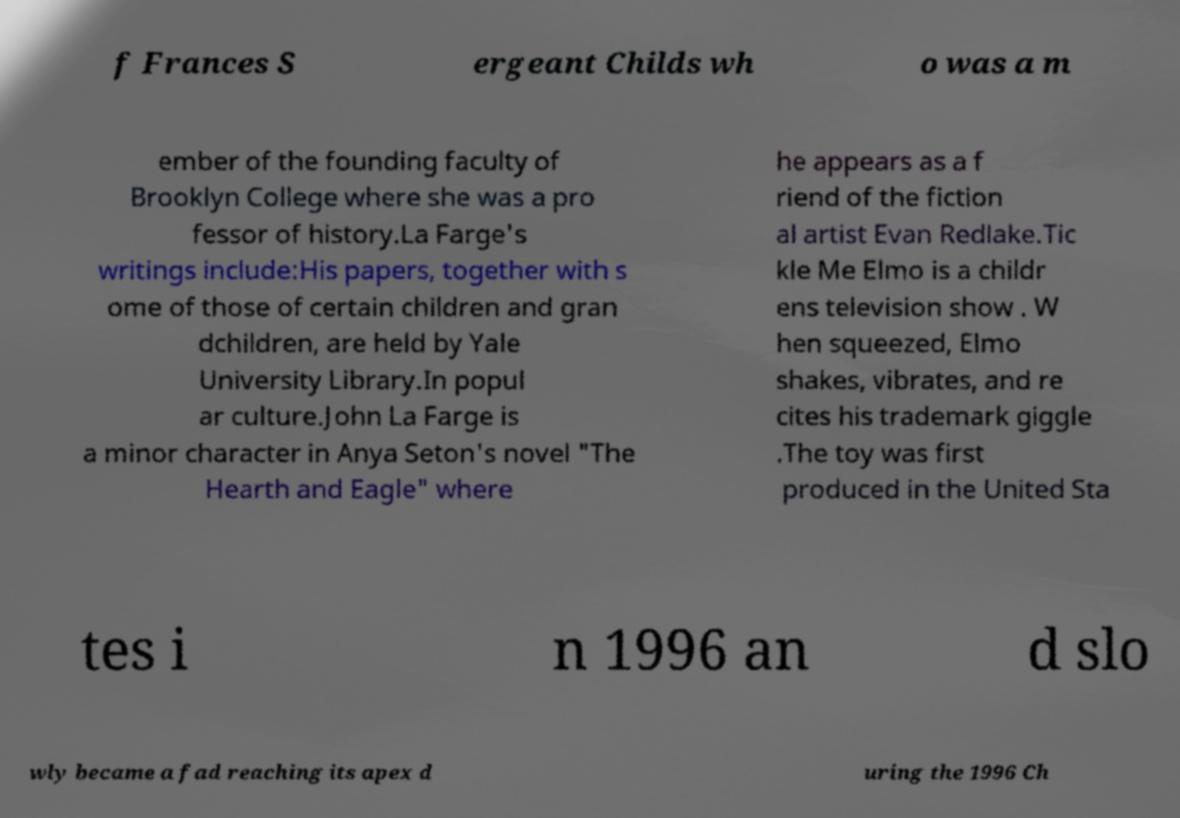Could you assist in decoding the text presented in this image and type it out clearly? f Frances S ergeant Childs wh o was a m ember of the founding faculty of Brooklyn College where she was a pro fessor of history.La Farge's writings include:His papers, together with s ome of those of certain children and gran dchildren, are held by Yale University Library.In popul ar culture.John La Farge is a minor character in Anya Seton's novel "The Hearth and Eagle" where he appears as a f riend of the fiction al artist Evan Redlake.Tic kle Me Elmo is a childr ens television show . W hen squeezed, Elmo shakes, vibrates, and re cites his trademark giggle .The toy was first produced in the United Sta tes i n 1996 an d slo wly became a fad reaching its apex d uring the 1996 Ch 